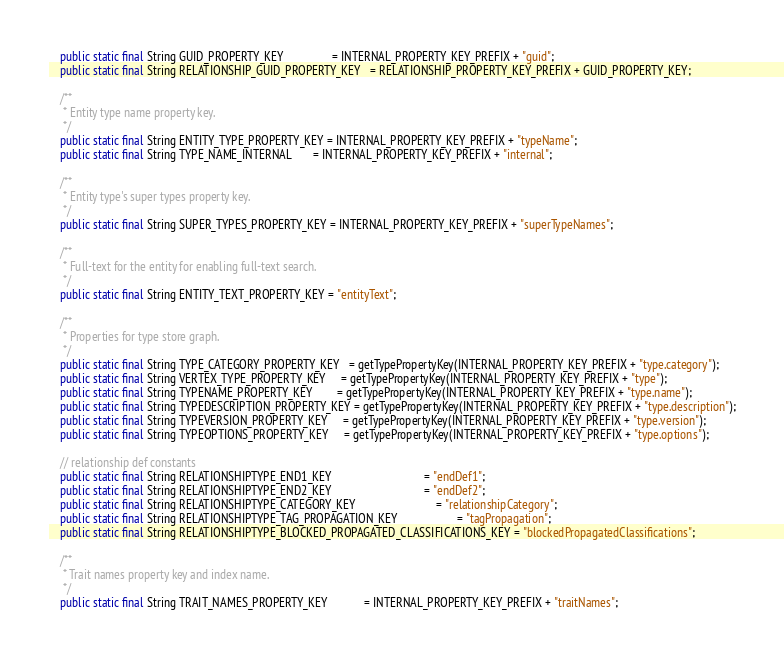<code> <loc_0><loc_0><loc_500><loc_500><_Java_>    public static final String GUID_PROPERTY_KEY                = INTERNAL_PROPERTY_KEY_PREFIX + "guid";
    public static final String RELATIONSHIP_GUID_PROPERTY_KEY   = RELATIONSHIP_PROPERTY_KEY_PREFIX + GUID_PROPERTY_KEY;

    /**
     * Entity type name property key.
     */
    public static final String ENTITY_TYPE_PROPERTY_KEY = INTERNAL_PROPERTY_KEY_PREFIX + "typeName";
    public static final String TYPE_NAME_INTERNAL       = INTERNAL_PROPERTY_KEY_PREFIX + "internal";

    /**
     * Entity type's super types property key.
     */
    public static final String SUPER_TYPES_PROPERTY_KEY = INTERNAL_PROPERTY_KEY_PREFIX + "superTypeNames";

    /**
     * Full-text for the entity for enabling full-text search.
     */
    public static final String ENTITY_TEXT_PROPERTY_KEY = "entityText";

    /**
     * Properties for type store graph.
     */
    public static final String TYPE_CATEGORY_PROPERTY_KEY   = getTypePropertyKey(INTERNAL_PROPERTY_KEY_PREFIX + "type.category");
    public static final String VERTEX_TYPE_PROPERTY_KEY     = getTypePropertyKey(INTERNAL_PROPERTY_KEY_PREFIX + "type");
    public static final String TYPENAME_PROPERTY_KEY        = getTypePropertyKey(INTERNAL_PROPERTY_KEY_PREFIX + "type.name");
    public static final String TYPEDESCRIPTION_PROPERTY_KEY = getTypePropertyKey(INTERNAL_PROPERTY_KEY_PREFIX + "type.description");
    public static final String TYPEVERSION_PROPERTY_KEY     = getTypePropertyKey(INTERNAL_PROPERTY_KEY_PREFIX + "type.version");
    public static final String TYPEOPTIONS_PROPERTY_KEY     = getTypePropertyKey(INTERNAL_PROPERTY_KEY_PREFIX + "type.options");

    // relationship def constants
    public static final String RELATIONSHIPTYPE_END1_KEY                               = "endDef1";
    public static final String RELATIONSHIPTYPE_END2_KEY                               = "endDef2";
    public static final String RELATIONSHIPTYPE_CATEGORY_KEY                           = "relationshipCategory";
    public static final String RELATIONSHIPTYPE_TAG_PROPAGATION_KEY                    = "tagPropagation";
    public static final String RELATIONSHIPTYPE_BLOCKED_PROPAGATED_CLASSIFICATIONS_KEY = "blockedPropagatedClassifications";

    /**
     * Trait names property key and index name.
     */
    public static final String TRAIT_NAMES_PROPERTY_KEY            = INTERNAL_PROPERTY_KEY_PREFIX + "traitNames";</code> 